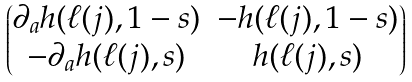Convert formula to latex. <formula><loc_0><loc_0><loc_500><loc_500>\begin{pmatrix} \partial _ { a } h ( \ell ( j ) , 1 - s ) & - h ( \ell ( j ) , 1 - s ) \\ - \partial _ { a } h ( \ell ( j ) , s ) & h ( \ell ( j ) , s ) \end{pmatrix}</formula> 